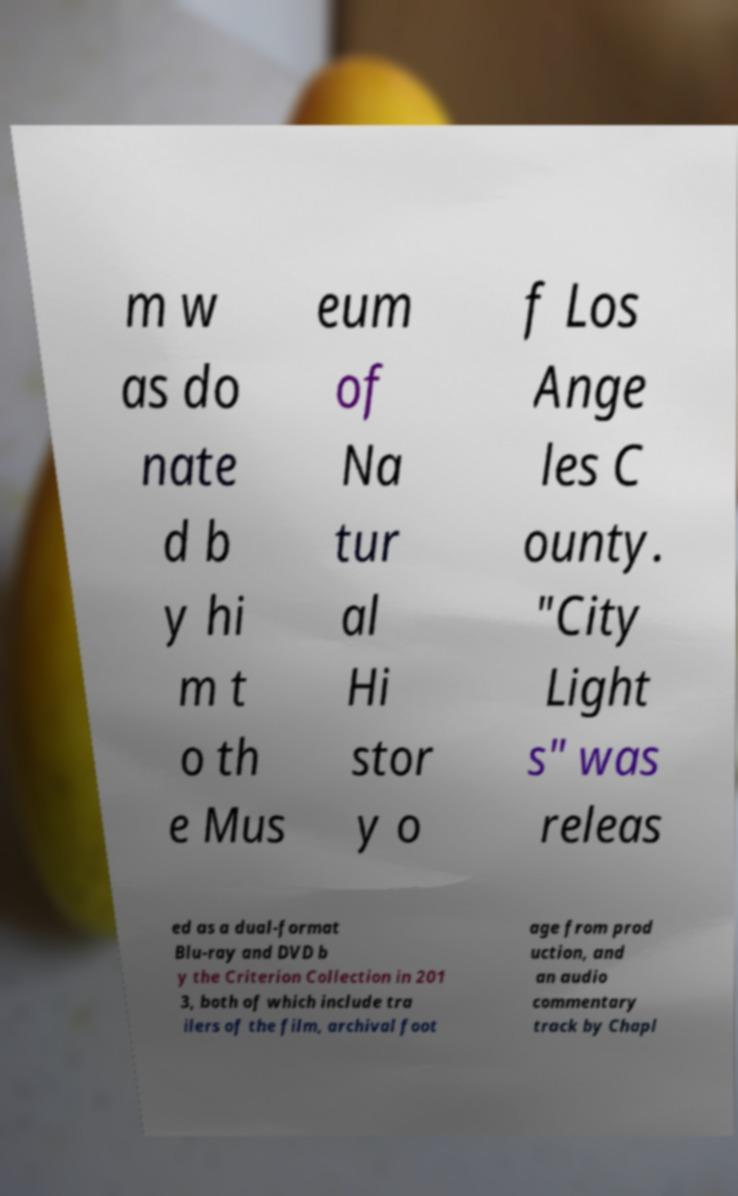Please read and relay the text visible in this image. What does it say? m w as do nate d b y hi m t o th e Mus eum of Na tur al Hi stor y o f Los Ange les C ounty. "City Light s" was releas ed as a dual-format Blu-ray and DVD b y the Criterion Collection in 201 3, both of which include tra ilers of the film, archival foot age from prod uction, and an audio commentary track by Chapl 